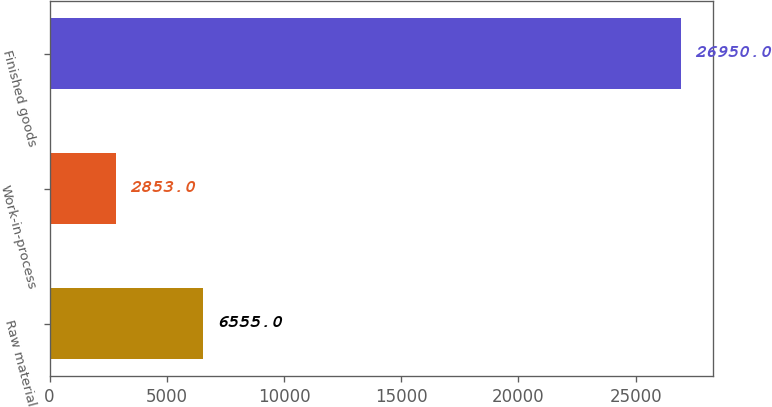Convert chart to OTSL. <chart><loc_0><loc_0><loc_500><loc_500><bar_chart><fcel>Raw material<fcel>Work-in-process<fcel>Finished goods<nl><fcel>6555<fcel>2853<fcel>26950<nl></chart> 